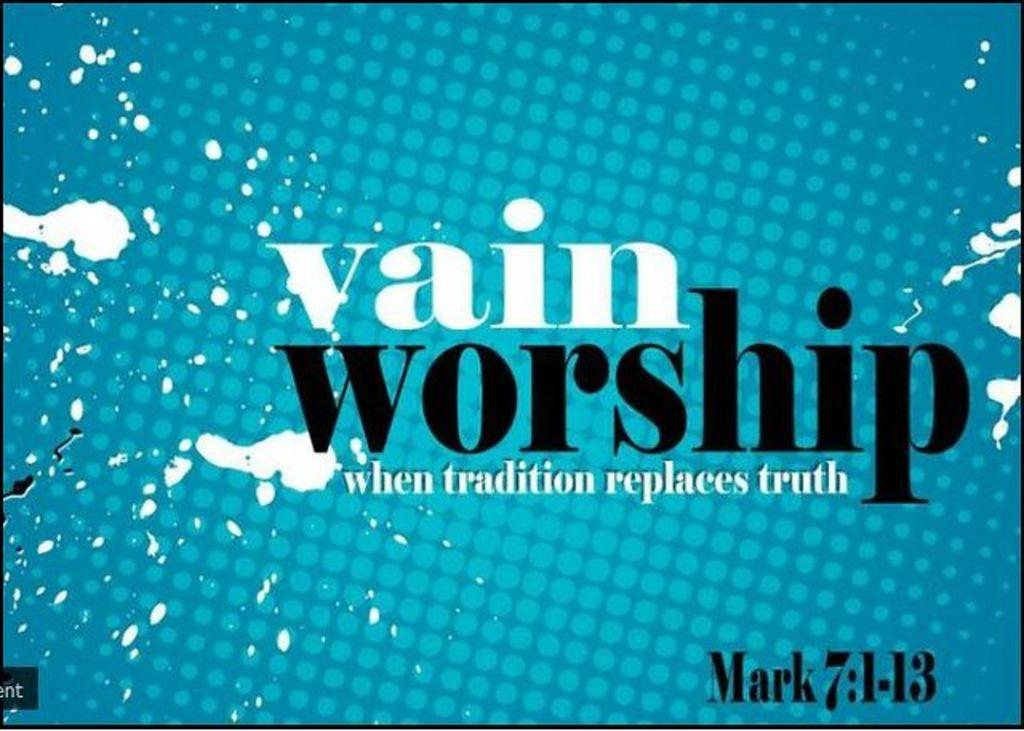Provide a one-sentence caption for the provided image. "Vain Worship" is written on this bible verse advert. 